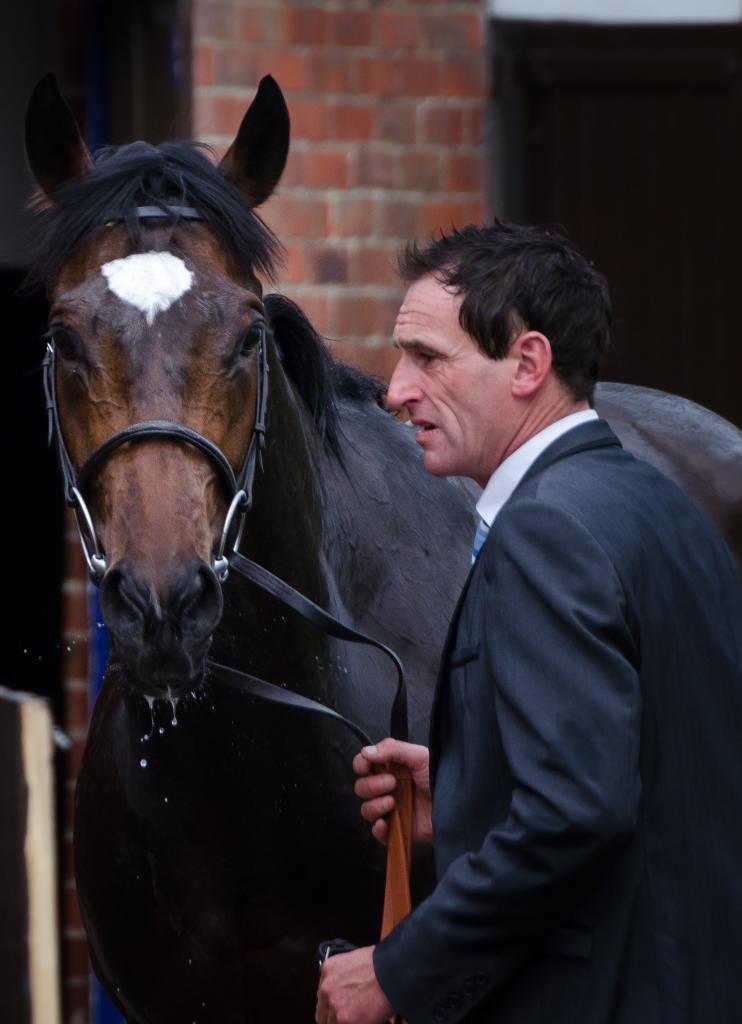In one or two sentences, can you explain what this image depicts? This picture shows a man holding a horse with a string. 